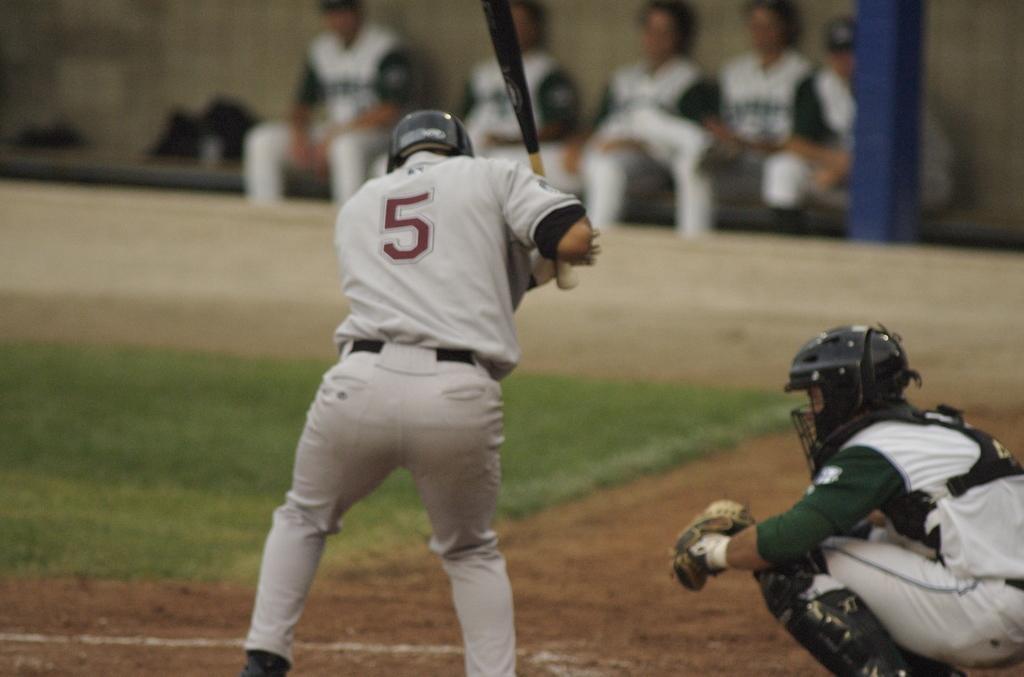Could you give a brief overview of what you see in this image? In the image in the center we can see one person standing and holding bat and he is wearing helmet. On the right side we can see one more person wearing helmet. In the background we can see wall,chairs,pole and few people were sitting. 